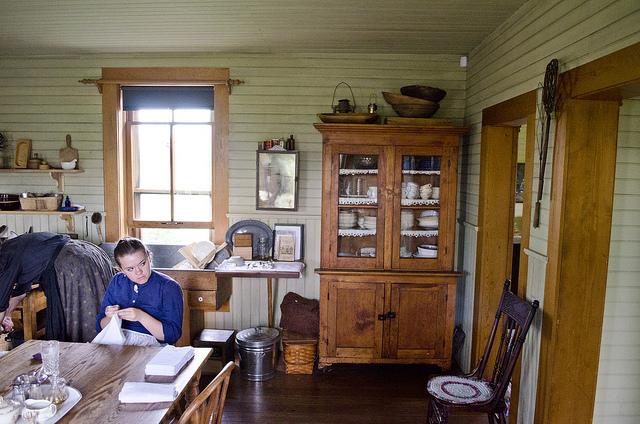What is on top of the cabinets?
Short answer required. Baskets. How many shades of blue are represented in the ladies' outfits in this picture?
Concise answer only. 1. Are there any people on the chairs?
Be succinct. Yes. Is this a luggage storage?
Keep it brief. No. How many STEMMED glasses are sitting on the shelves?
Answer briefly. 0. What is the woman doing?
Give a very brief answer. Sewing. Are there any adults in the picture?
Quick response, please. Yes. How many people are sitting?
Answer briefly. 1. How many people are in the room?
Keep it brief. 2. What is the person holding?
Concise answer only. Cloth. Is there a child at the table?
Be succinct. No. How many windows are in the picture?
Give a very brief answer. 1. Is the girl's hair down?
Quick response, please. No. Is the table set?
Answer briefly. No. Is this floor carpeted?
Short answer required. No. 